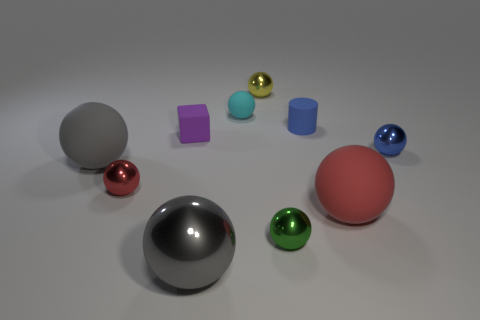Does the small red sphere have the same material as the blue object behind the blue metallic ball?
Provide a short and direct response. No. There is a large gray thing that is in front of the rubber sphere that is to the left of the cyan thing; what shape is it?
Provide a succinct answer. Sphere. There is a tiny cylinder; is its color the same as the small sphere on the right side of the tiny green object?
Keep it short and to the point. Yes. There is a tiny green thing; what shape is it?
Give a very brief answer. Sphere. What is the size of the red object that is on the right side of the green object that is in front of the tiny red metal object?
Your response must be concise. Large. Are there the same number of tiny yellow things that are left of the small cyan ball and small red shiny balls on the right side of the tiny blue shiny object?
Your answer should be compact. Yes. There is a tiny object that is in front of the blue metal ball and to the left of the gray shiny ball; what is it made of?
Your answer should be compact. Metal. There is a cylinder; is its size the same as the matte sphere that is on the right side of the yellow shiny sphere?
Offer a very short reply. No. What number of other things are the same color as the small block?
Keep it short and to the point. 0. Are there more small cubes in front of the red metal object than large gray matte cylinders?
Ensure brevity in your answer.  No. 